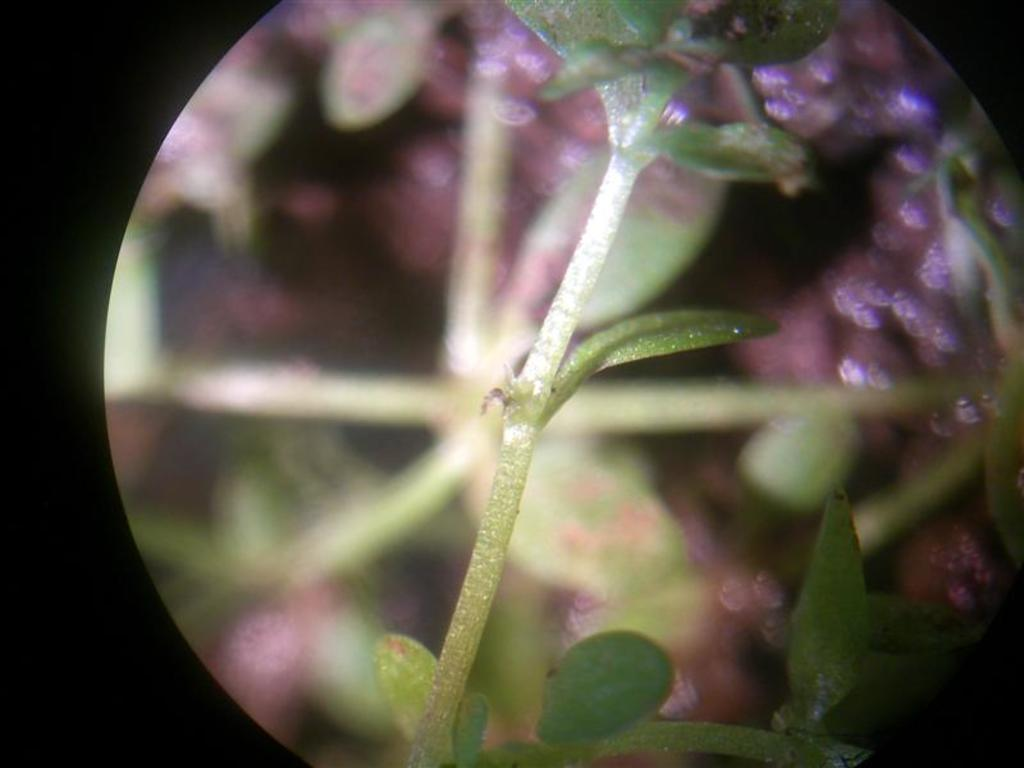What is present in the image? There is a plant in the image. Can you describe the background of the image? The background of the image is blurred. How many nuts are visible in the image? There are no nuts present in the image; it only features a plant. What type of boot is shown in the image? There is no boot present in the image. 